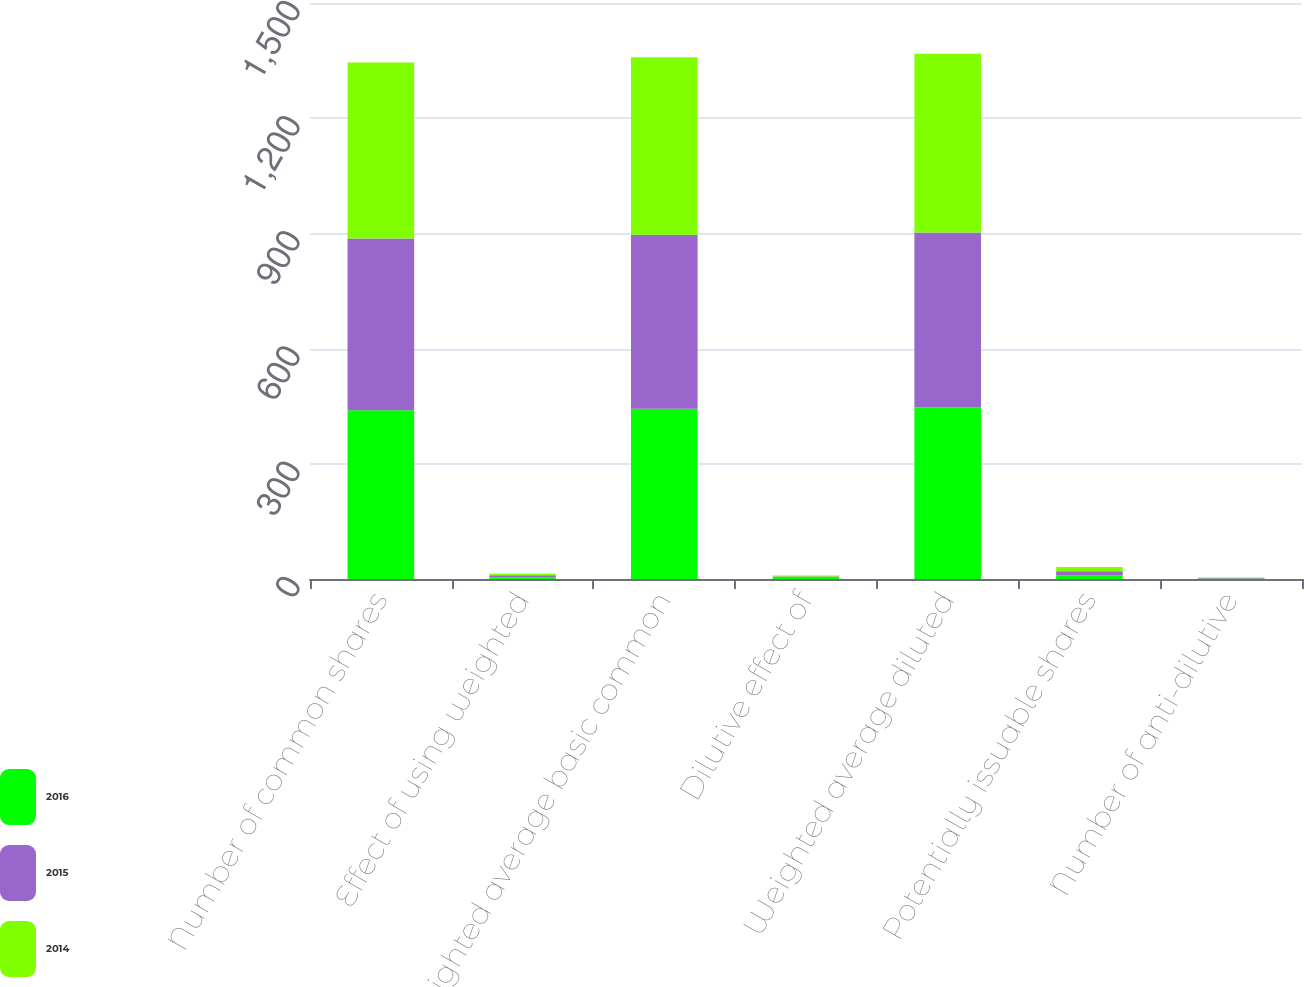Convert chart. <chart><loc_0><loc_0><loc_500><loc_500><stacked_bar_chart><ecel><fcel>Number of common shares<fcel>Effect of using weighted<fcel>Weighted average basic common<fcel>Dilutive effect of<fcel>Weighted average diluted<fcel>Potentially issuable shares<fcel>Number of anti-dilutive<nl><fcel>2016<fcel>439.3<fcel>4.2<fcel>443.5<fcel>3<fcel>446.5<fcel>9.8<fcel>1<nl><fcel>2015<fcel>447.2<fcel>5.5<fcel>452.7<fcel>3.2<fcel>455.9<fcel>10.2<fcel>2<nl><fcel>2014<fcel>458.5<fcel>4.1<fcel>462.6<fcel>3<fcel>465.6<fcel>11.3<fcel>0.4<nl></chart> 